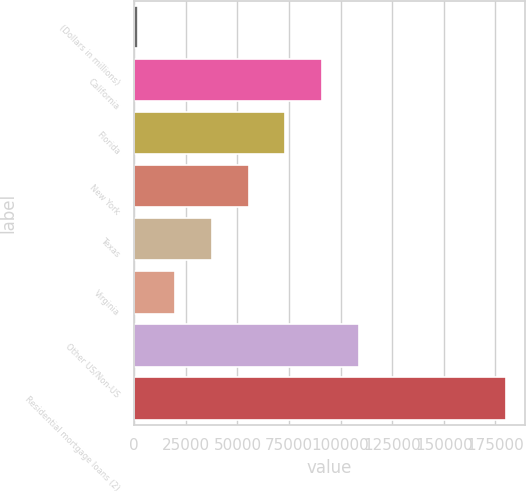Convert chart to OTSL. <chart><loc_0><loc_0><loc_500><loc_500><bar_chart><fcel>(Dollars in millions)<fcel>California<fcel>Florida<fcel>New York<fcel>Texas<fcel>Virginia<fcel>Other US/Non-US<fcel>Residential mortgage loans (2)<nl><fcel>2010<fcel>91073<fcel>73260.4<fcel>55447.8<fcel>37635.2<fcel>19822.6<fcel>108886<fcel>180136<nl></chart> 